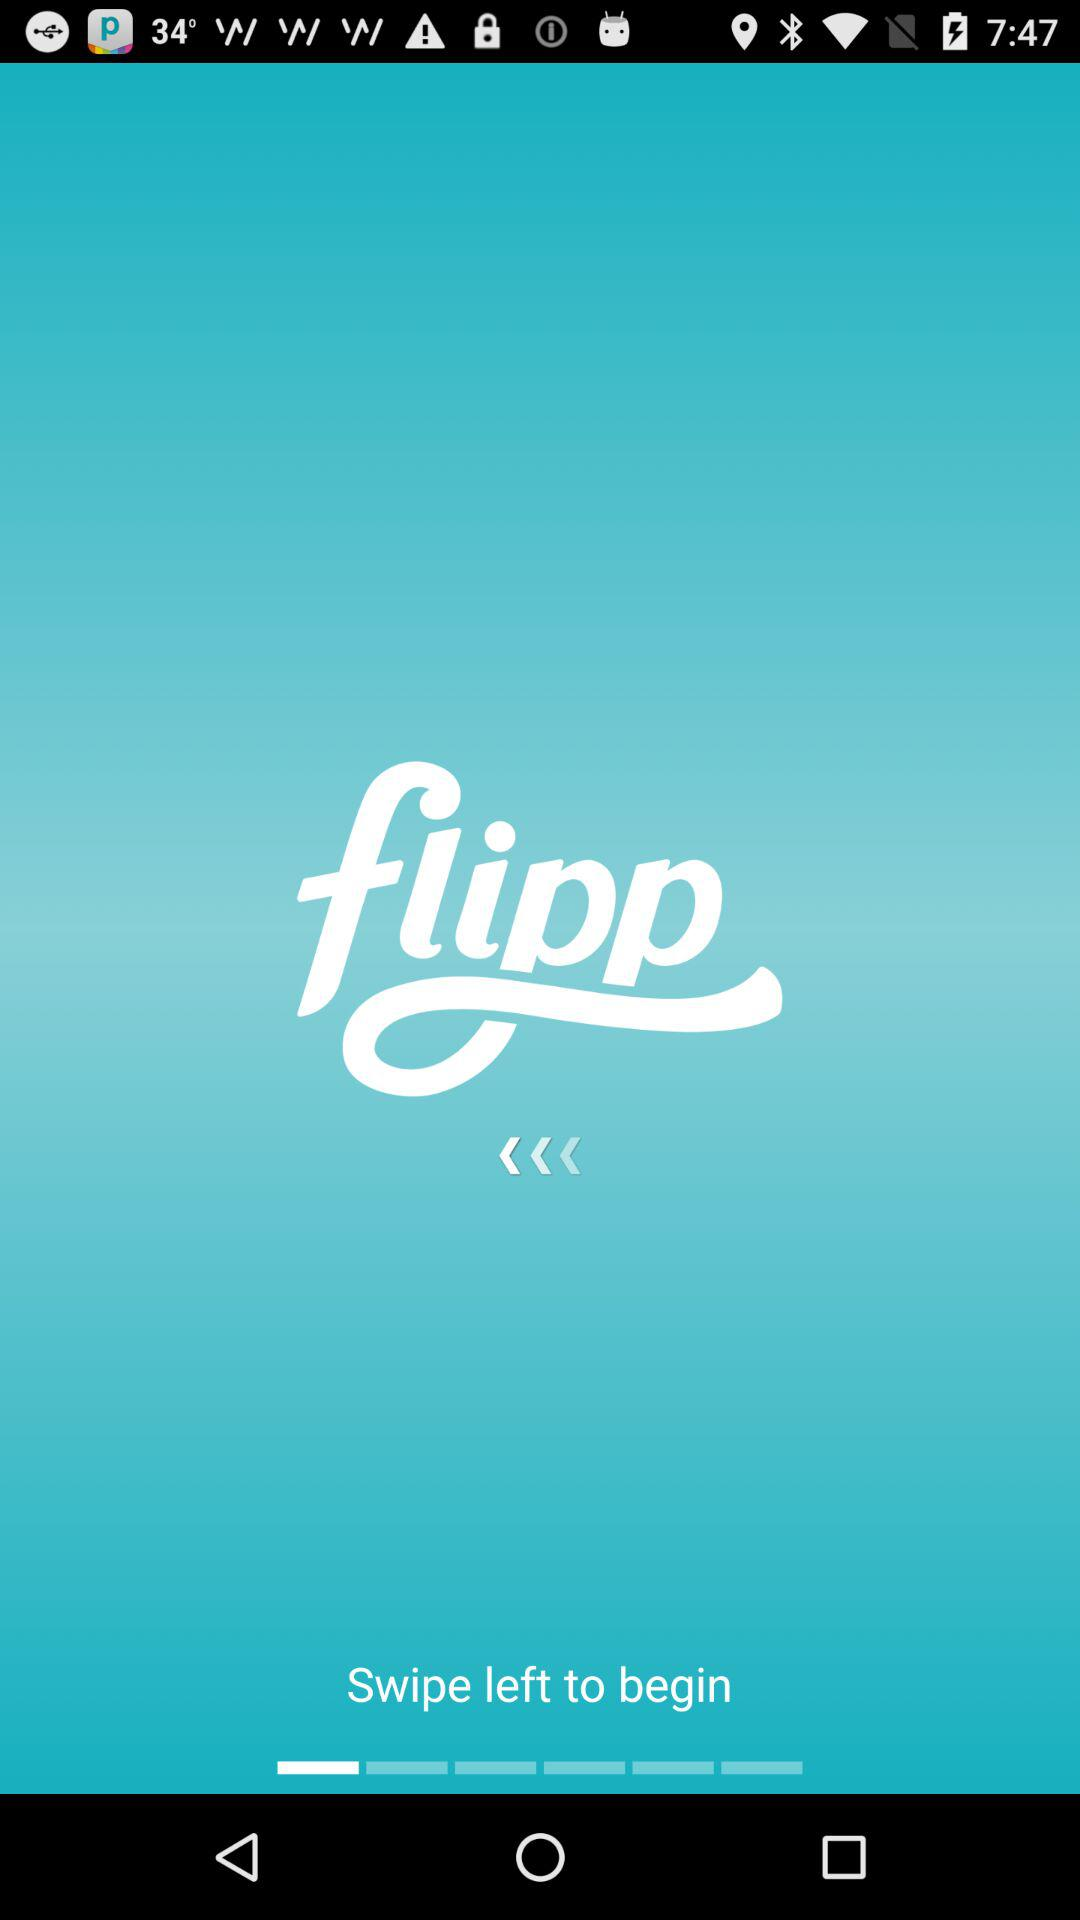What is the app name? The app name is "Flipp". 